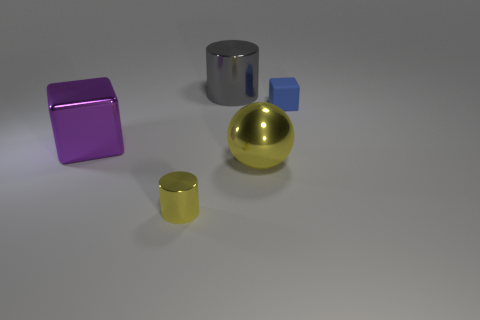There is a object on the left side of the cylinder that is in front of the metal cylinder behind the tiny blue block; what is its color?
Offer a terse response. Purple. Are there the same number of big shiny cylinders that are in front of the large yellow object and gray blocks?
Your answer should be very brief. Yes. Is there anything else that is the same material as the tiny blue cube?
Your response must be concise. No. Do the tiny metal cylinder and the large metal thing that is right of the large gray thing have the same color?
Offer a very short reply. Yes. There is a block that is on the right side of the yellow thing right of the gray shiny thing; are there any small objects in front of it?
Make the answer very short. Yes. Are there fewer blue matte things that are to the left of the blue thing than large cylinders?
Make the answer very short. Yes. What number of other things are there of the same shape as the big yellow metal thing?
Your response must be concise. 0. What number of objects are cylinders behind the yellow shiny cylinder or objects right of the tiny cylinder?
Keep it short and to the point. 3. There is a object that is both left of the small cube and behind the big purple metallic thing; what is its size?
Keep it short and to the point. Large. Does the big thing that is behind the purple metallic thing have the same shape as the tiny metal object?
Ensure brevity in your answer.  Yes. 